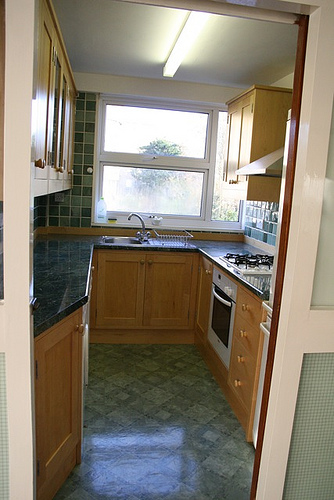Imagine a fantastical scenario involving this kitchen. In a fantastical scenario, imagine this kitchen as the heart of a magical cottage in an enchanted forest. The cabinets, made from enchanted wood, can replenish ingredients as they're used. The window above the sink offers a view of fairies dancing outside, and the bottle on the countertop contains a mysterious potion that can grant wishes. The owner, a benevolent witch, uses this kitchen to concoct potions and prepare feasts for travelers who stumble upon her hidden home, providing them with warmth and comfort. 